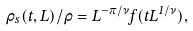<formula> <loc_0><loc_0><loc_500><loc_500>\rho _ { s } ( t , L ) / \rho = L ^ { - \pi / \nu } f ( t L ^ { 1 / \nu } ) ,</formula> 